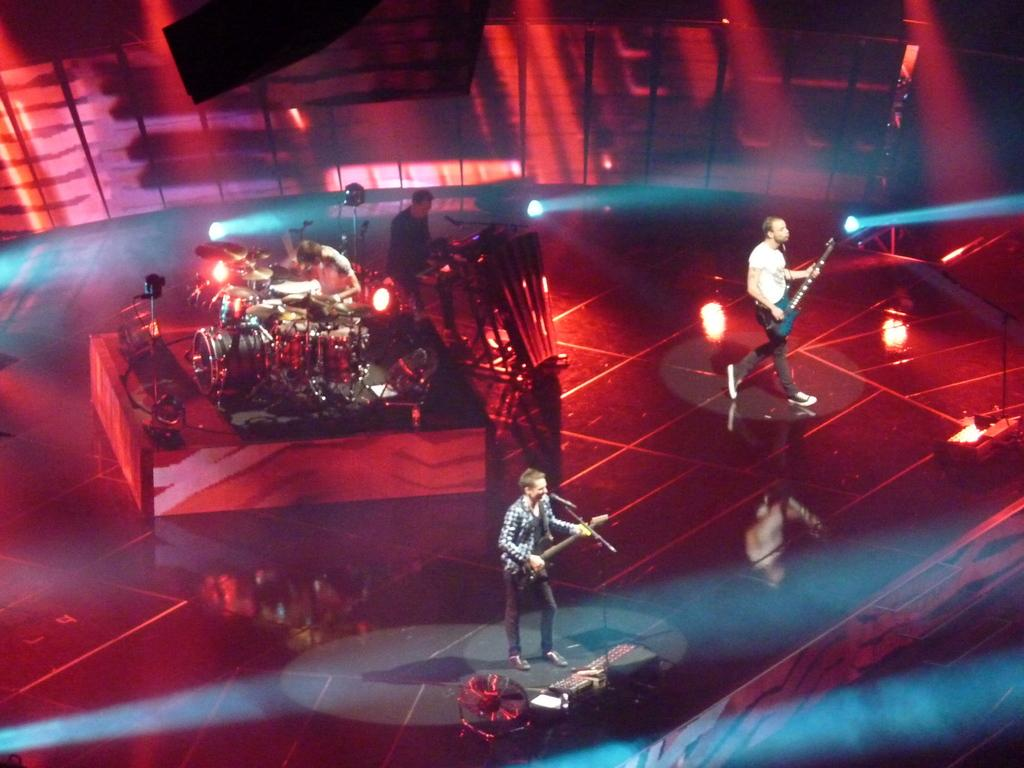What are the two persons in the image doing? The two persons in the image are playing guitar. How many other persons are playing musical instruments in the image? There are two other persons playing musical instruments in the image. What is the color of the background in the image? The background of the image is in red color. How does the balance of the guitar affect the sound in the image? There is no information about the balance of the guitar in the image, so it cannot be determined how it affects the sound. 